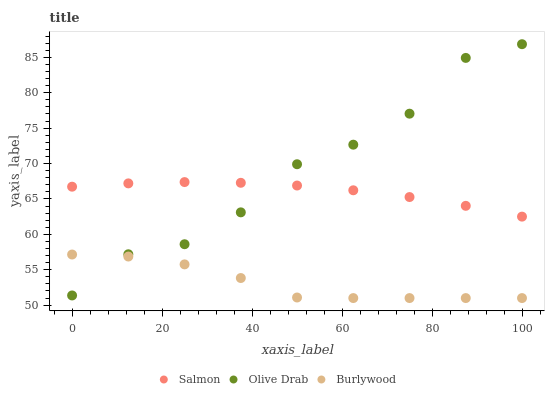Does Burlywood have the minimum area under the curve?
Answer yes or no. Yes. Does Olive Drab have the maximum area under the curve?
Answer yes or no. Yes. Does Salmon have the minimum area under the curve?
Answer yes or no. No. Does Salmon have the maximum area under the curve?
Answer yes or no. No. Is Salmon the smoothest?
Answer yes or no. Yes. Is Olive Drab the roughest?
Answer yes or no. Yes. Is Olive Drab the smoothest?
Answer yes or no. No. Is Salmon the roughest?
Answer yes or no. No. Does Burlywood have the lowest value?
Answer yes or no. Yes. Does Olive Drab have the lowest value?
Answer yes or no. No. Does Olive Drab have the highest value?
Answer yes or no. Yes. Does Salmon have the highest value?
Answer yes or no. No. Is Burlywood less than Salmon?
Answer yes or no. Yes. Is Salmon greater than Burlywood?
Answer yes or no. Yes. Does Salmon intersect Olive Drab?
Answer yes or no. Yes. Is Salmon less than Olive Drab?
Answer yes or no. No. Is Salmon greater than Olive Drab?
Answer yes or no. No. Does Burlywood intersect Salmon?
Answer yes or no. No. 